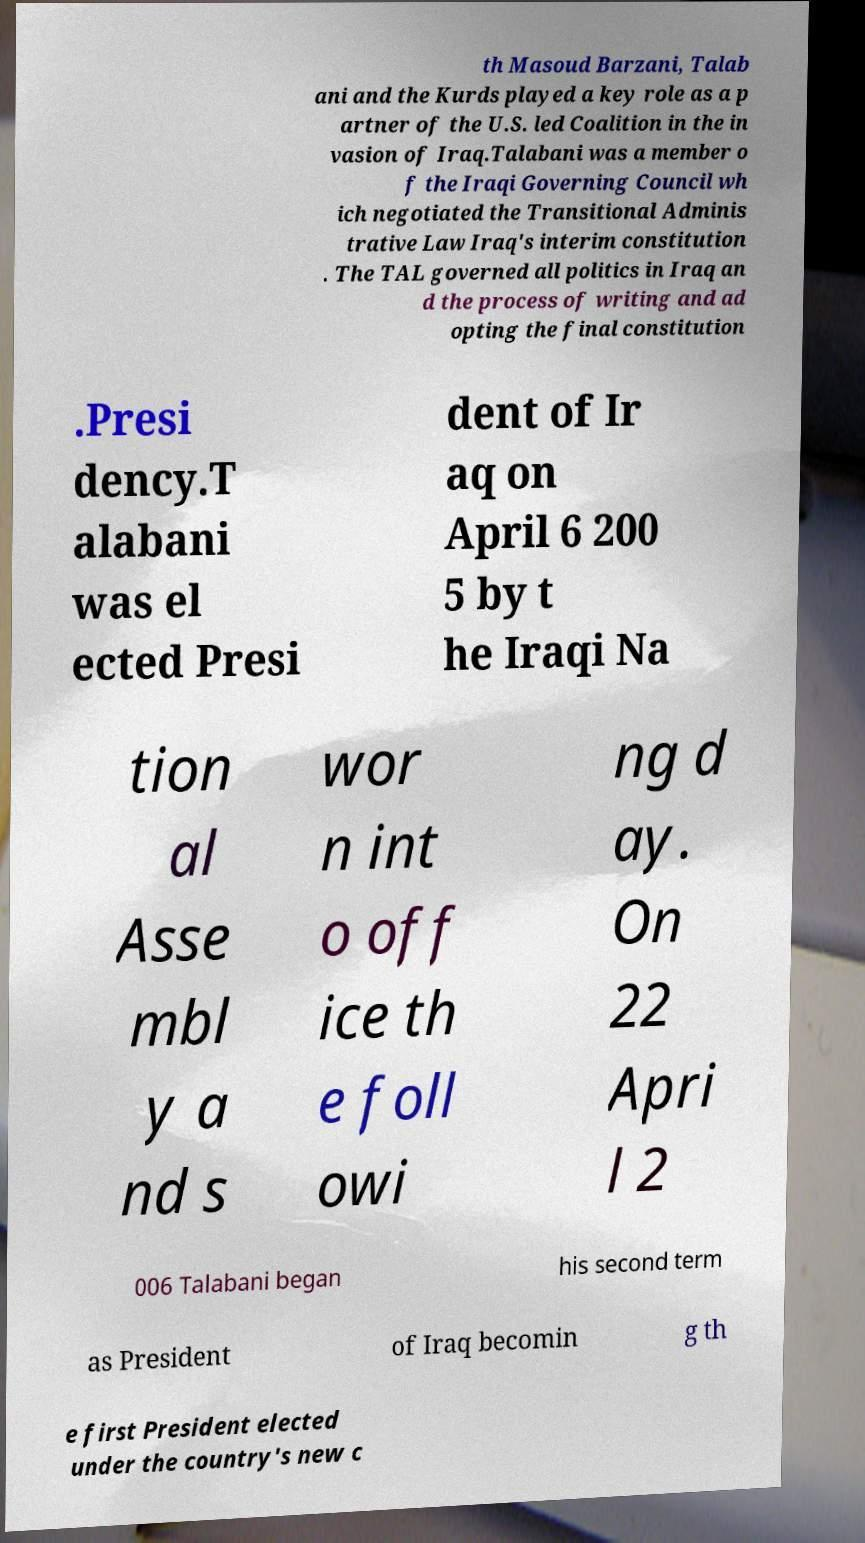For documentation purposes, I need the text within this image transcribed. Could you provide that? th Masoud Barzani, Talab ani and the Kurds played a key role as a p artner of the U.S. led Coalition in the in vasion of Iraq.Talabani was a member o f the Iraqi Governing Council wh ich negotiated the Transitional Adminis trative Law Iraq's interim constitution . The TAL governed all politics in Iraq an d the process of writing and ad opting the final constitution .Presi dency.T alabani was el ected Presi dent of Ir aq on April 6 200 5 by t he Iraqi Na tion al Asse mbl y a nd s wor n int o off ice th e foll owi ng d ay. On 22 Apri l 2 006 Talabani began his second term as President of Iraq becomin g th e first President elected under the country's new c 